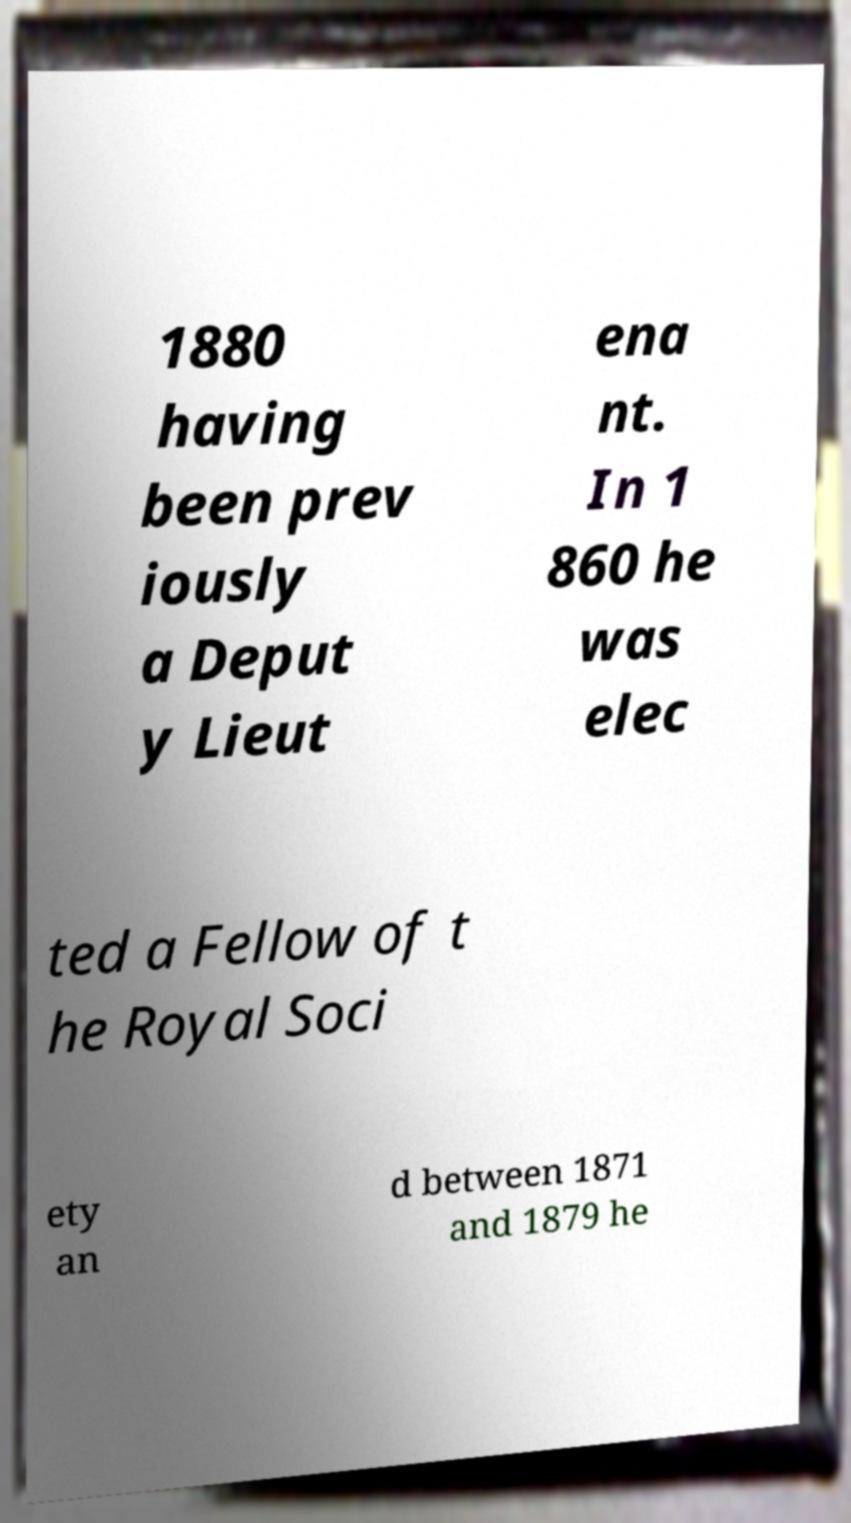I need the written content from this picture converted into text. Can you do that? 1880 having been prev iously a Deput y Lieut ena nt. In 1 860 he was elec ted a Fellow of t he Royal Soci ety an d between 1871 and 1879 he 